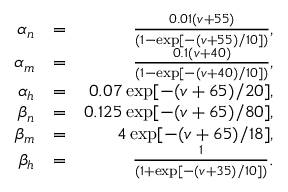<formula> <loc_0><loc_0><loc_500><loc_500>\begin{array} { r l r } { \alpha _ { n } } & { = } & { \frac { 0 . 0 1 ( v + 5 5 ) } { ( 1 - \exp [ - ( v + 5 5 ) / 1 0 ] ) } , } \\ { \alpha _ { m } } & { = } & { \frac { 0 . 1 ( v + 4 0 ) } { ( 1 - \exp [ - ( v + 4 0 ) / 1 0 ] ) } , } \\ { \alpha _ { h } } & { = } & { 0 . 0 7 \exp [ - ( v + 6 5 ) / 2 0 ] , } \\ { \beta _ { n } } & { = } & { 0 . 1 2 5 \exp [ - ( v + 6 5 ) / 8 0 ] , } \\ { \beta _ { m } } & { = } & { 4 \exp [ - ( v + 6 5 ) / 1 8 ] , } \\ { \beta _ { h } } & { = } & { \frac { 1 } { ( 1 + \exp [ - ( v + 3 5 ) / 1 0 ] ) } . } \end{array}</formula> 